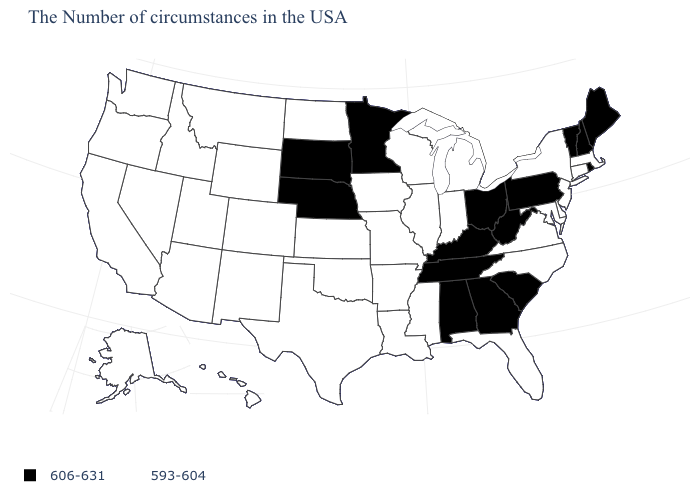Among the states that border Alabama , which have the lowest value?
Keep it brief. Florida, Mississippi. Name the states that have a value in the range 593-604?
Give a very brief answer. Massachusetts, Connecticut, New York, New Jersey, Delaware, Maryland, Virginia, North Carolina, Florida, Michigan, Indiana, Wisconsin, Illinois, Mississippi, Louisiana, Missouri, Arkansas, Iowa, Kansas, Oklahoma, Texas, North Dakota, Wyoming, Colorado, New Mexico, Utah, Montana, Arizona, Idaho, Nevada, California, Washington, Oregon, Alaska, Hawaii. How many symbols are there in the legend?
Short answer required. 2. Name the states that have a value in the range 593-604?
Short answer required. Massachusetts, Connecticut, New York, New Jersey, Delaware, Maryland, Virginia, North Carolina, Florida, Michigan, Indiana, Wisconsin, Illinois, Mississippi, Louisiana, Missouri, Arkansas, Iowa, Kansas, Oklahoma, Texas, North Dakota, Wyoming, Colorado, New Mexico, Utah, Montana, Arizona, Idaho, Nevada, California, Washington, Oregon, Alaska, Hawaii. Does Missouri have the highest value in the USA?
Give a very brief answer. No. Name the states that have a value in the range 593-604?
Keep it brief. Massachusetts, Connecticut, New York, New Jersey, Delaware, Maryland, Virginia, North Carolina, Florida, Michigan, Indiana, Wisconsin, Illinois, Mississippi, Louisiana, Missouri, Arkansas, Iowa, Kansas, Oklahoma, Texas, North Dakota, Wyoming, Colorado, New Mexico, Utah, Montana, Arizona, Idaho, Nevada, California, Washington, Oregon, Alaska, Hawaii. Among the states that border Nevada , which have the lowest value?
Concise answer only. Utah, Arizona, Idaho, California, Oregon. Does Louisiana have the lowest value in the South?
Quick response, please. Yes. What is the value of Arizona?
Answer briefly. 593-604. Name the states that have a value in the range 606-631?
Quick response, please. Maine, Rhode Island, New Hampshire, Vermont, Pennsylvania, South Carolina, West Virginia, Ohio, Georgia, Kentucky, Alabama, Tennessee, Minnesota, Nebraska, South Dakota. Does the first symbol in the legend represent the smallest category?
Be succinct. No. Does New Hampshire have the same value as Vermont?
Quick response, please. Yes. Name the states that have a value in the range 606-631?
Quick response, please. Maine, Rhode Island, New Hampshire, Vermont, Pennsylvania, South Carolina, West Virginia, Ohio, Georgia, Kentucky, Alabama, Tennessee, Minnesota, Nebraska, South Dakota. 